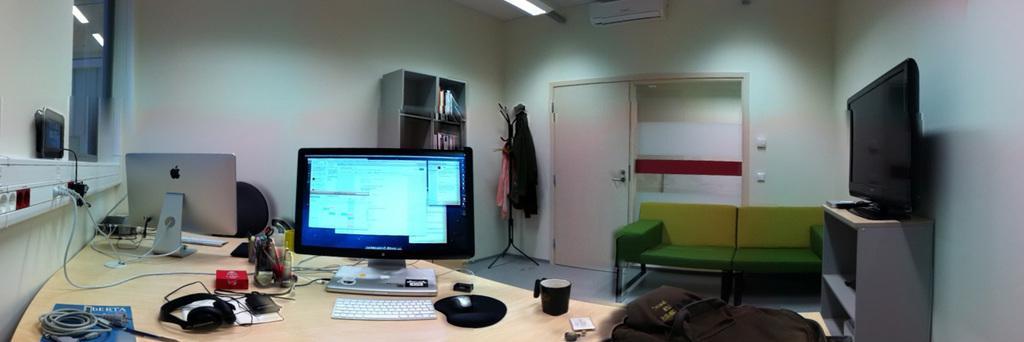In one or two sentences, can you explain what this image depicts? In this picture we can see a table, table consist of a monitor, one keyboard and mouse on the right side of the table there is a cup, on the left side of the table we can see one more monitor and a headset here, on the right most of the image we can see a television and in the background can see a door, on the left side of the image there is a cupboard, on the corner of the room we can see some clothes, on the left most of the picture there is a window. 